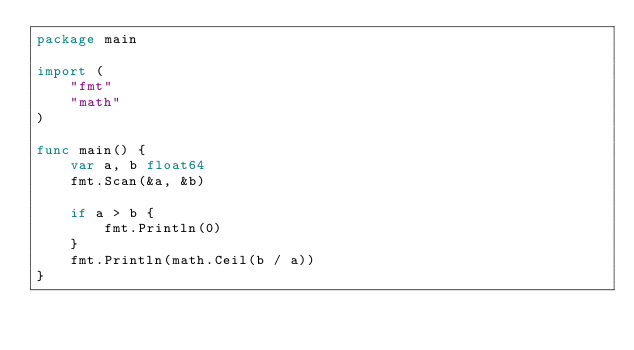Convert code to text. <code><loc_0><loc_0><loc_500><loc_500><_Go_>package main

import (
	"fmt"
	"math"
)

func main() {
	var a, b float64
	fmt.Scan(&a, &b)

	if a > b {
		fmt.Println(0)
	}
	fmt.Println(math.Ceil(b / a))
}
</code> 